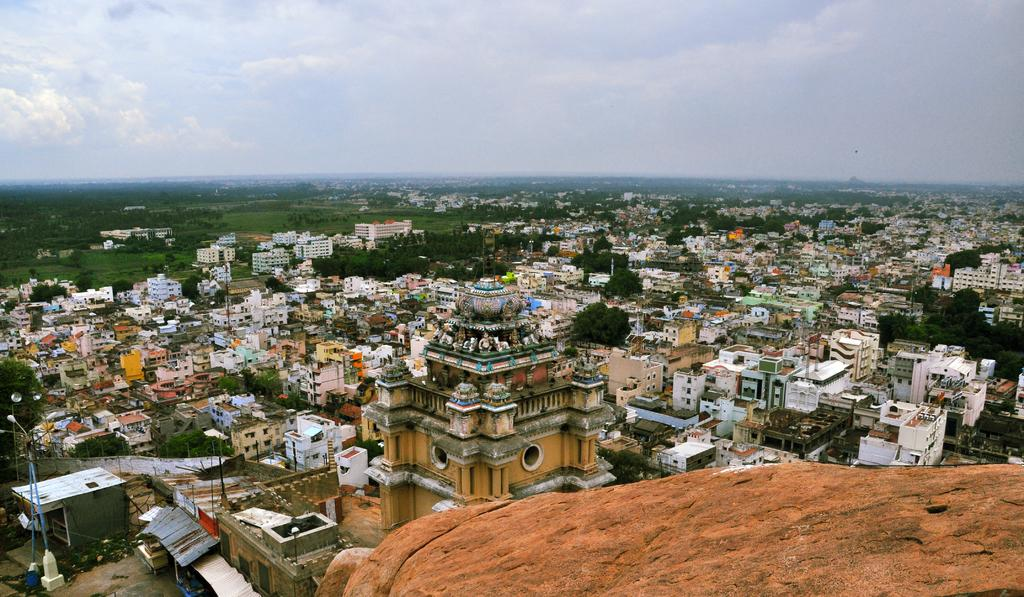What type of view is shown in the image? The image is a top view of a city. What types of buildings can be seen in the image? There are houses and a temple in the image. What type of landscape is visible in the image? There are fields in the image. What is visible in the background of the image? The sky is visible in the background of the image. What is the tendency of the houses to move in the image? The houses do not move in the image; they are stationary buildings. What type of peace is depicted in the image? The image does not depict any specific type of peace; it is a view of a city with houses, a temple, fields, and the sky. 